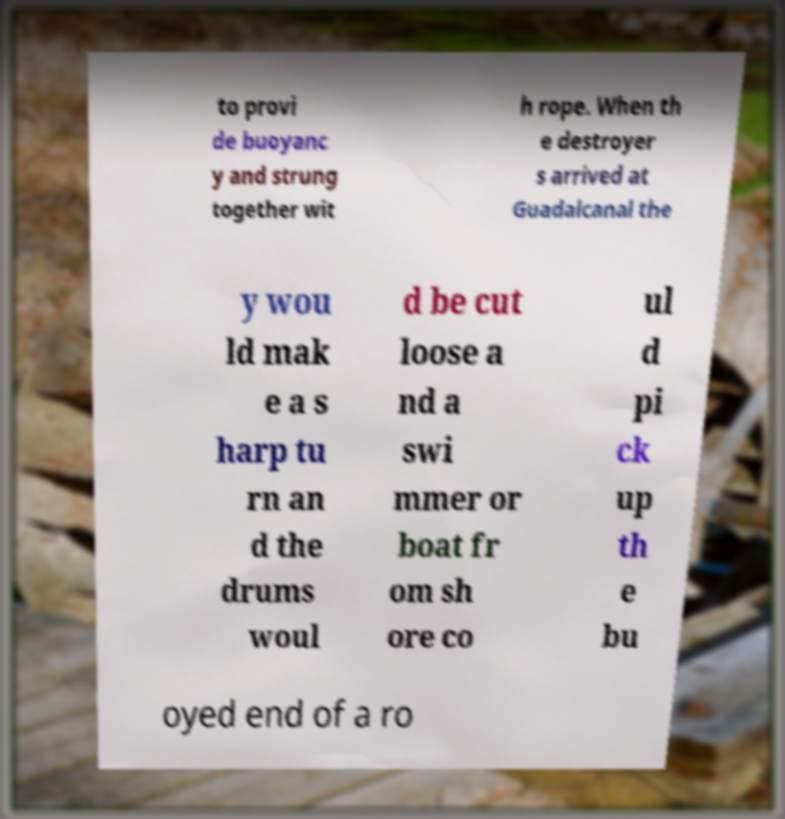Please identify and transcribe the text found in this image. to provi de buoyanc y and strung together wit h rope. When th e destroyer s arrived at Guadalcanal the y wou ld mak e a s harp tu rn an d the drums woul d be cut loose a nd a swi mmer or boat fr om sh ore co ul d pi ck up th e bu oyed end of a ro 